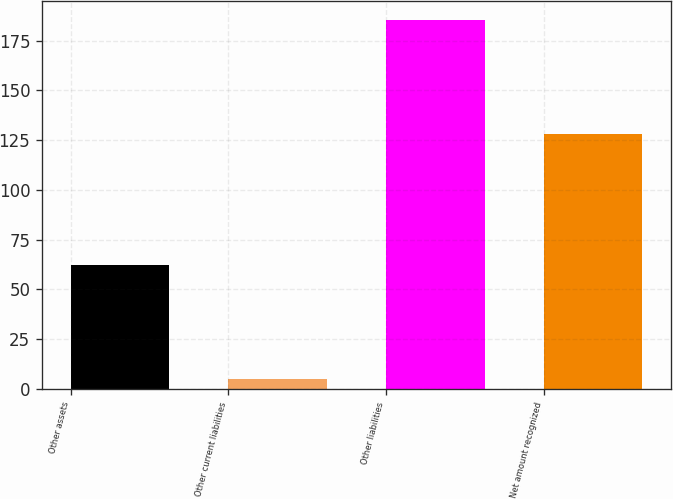Convert chart to OTSL. <chart><loc_0><loc_0><loc_500><loc_500><bar_chart><fcel>Other assets<fcel>Other current liabilities<fcel>Other liabilities<fcel>Net amount recognized<nl><fcel>62.3<fcel>5.1<fcel>185.5<fcel>128.3<nl></chart> 